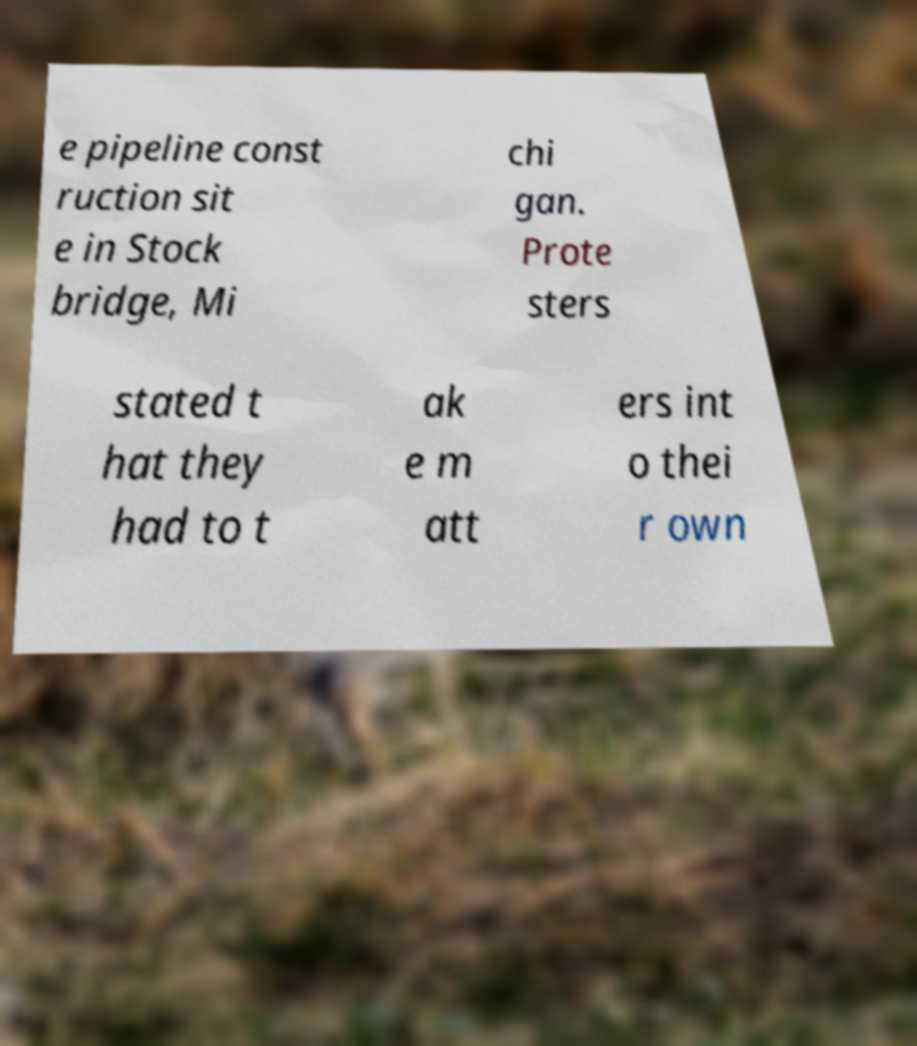Could you extract and type out the text from this image? e pipeline const ruction sit e in Stock bridge, Mi chi gan. Prote sters stated t hat they had to t ak e m att ers int o thei r own 